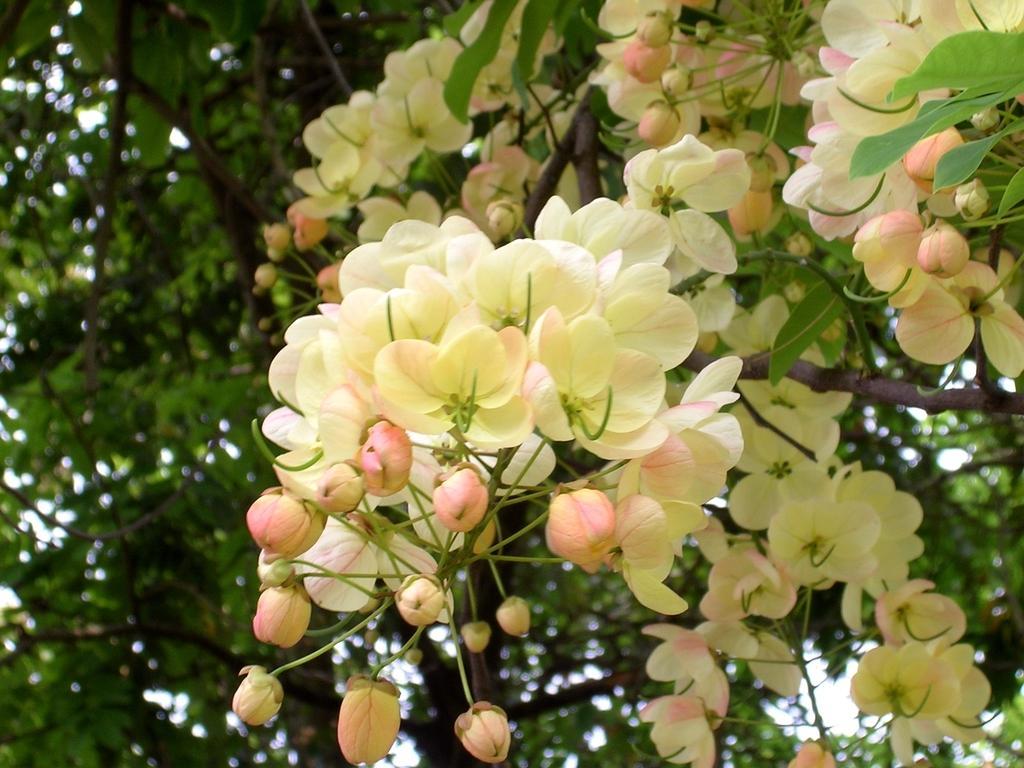Please provide a concise description of this image. In this image we can see flowers, buds, branches, and leaves. 